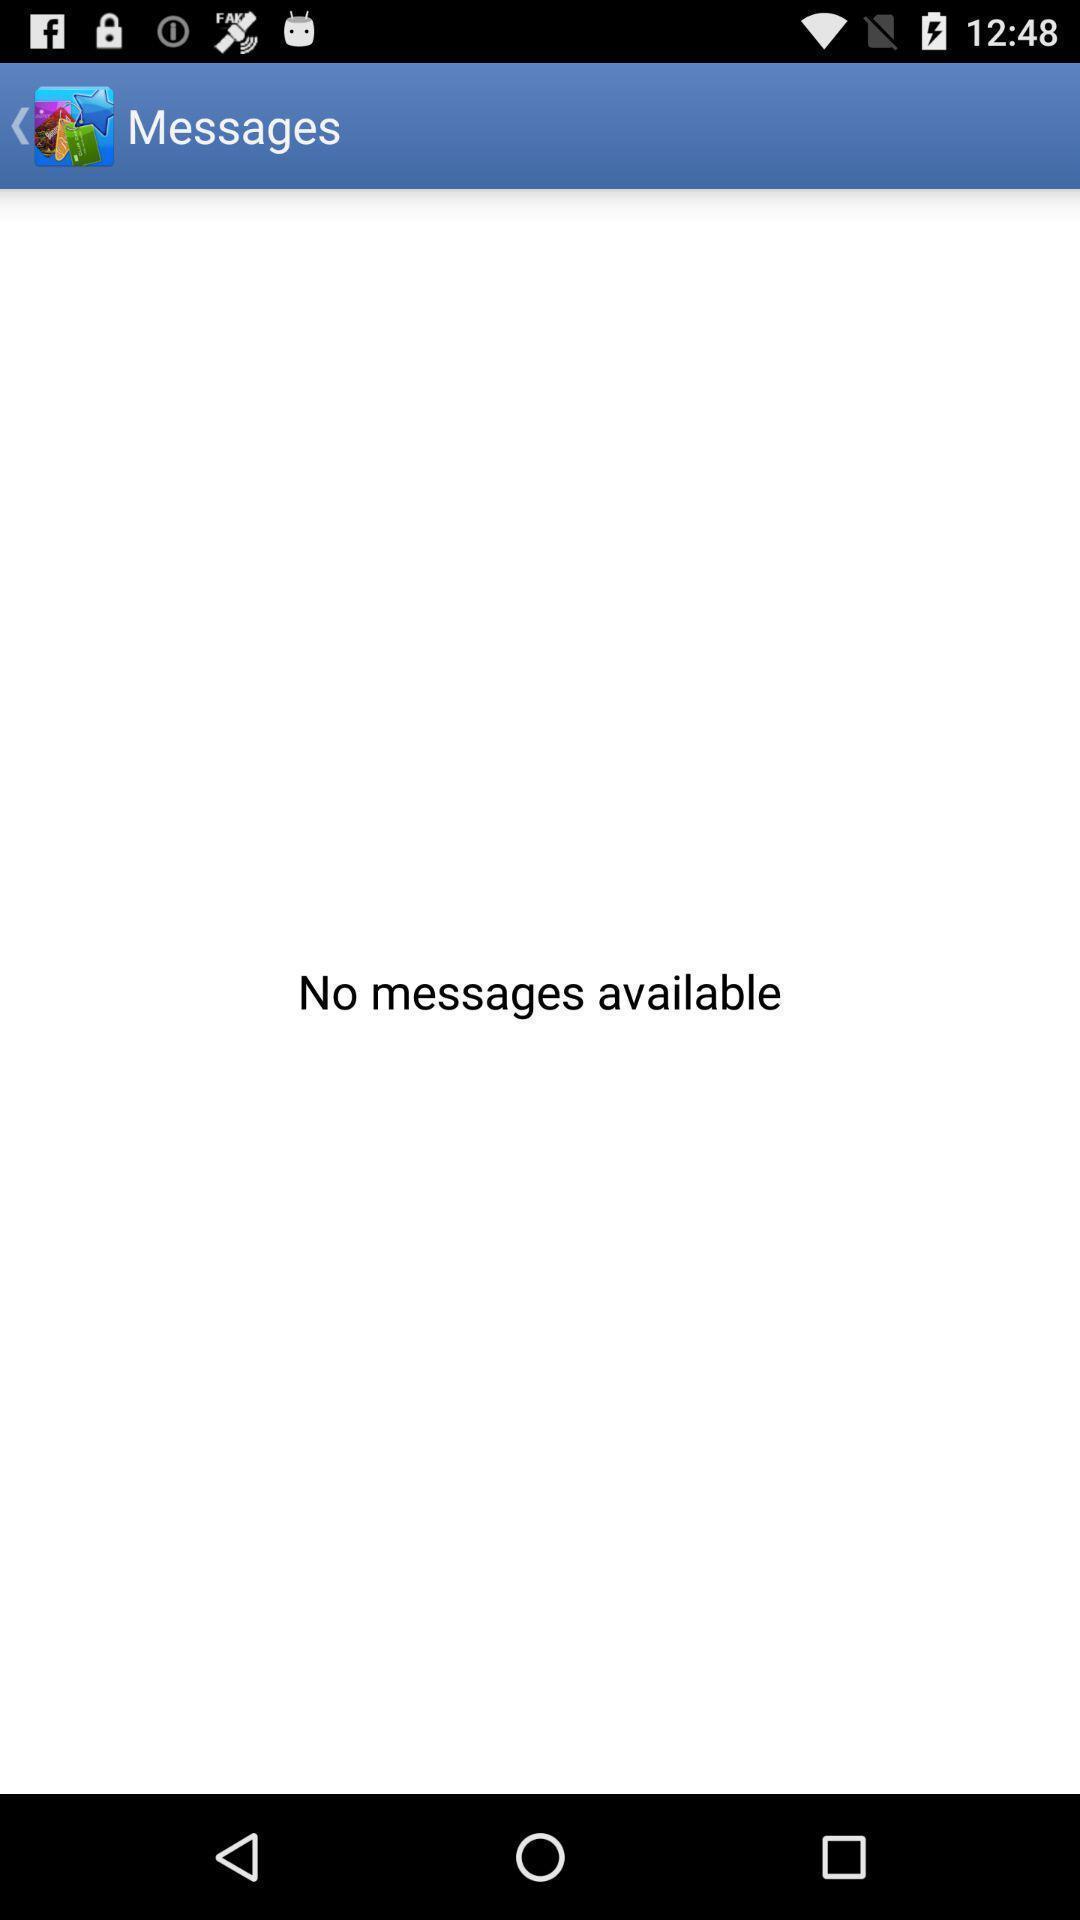Please provide a description for this image. Screen shows messages. 